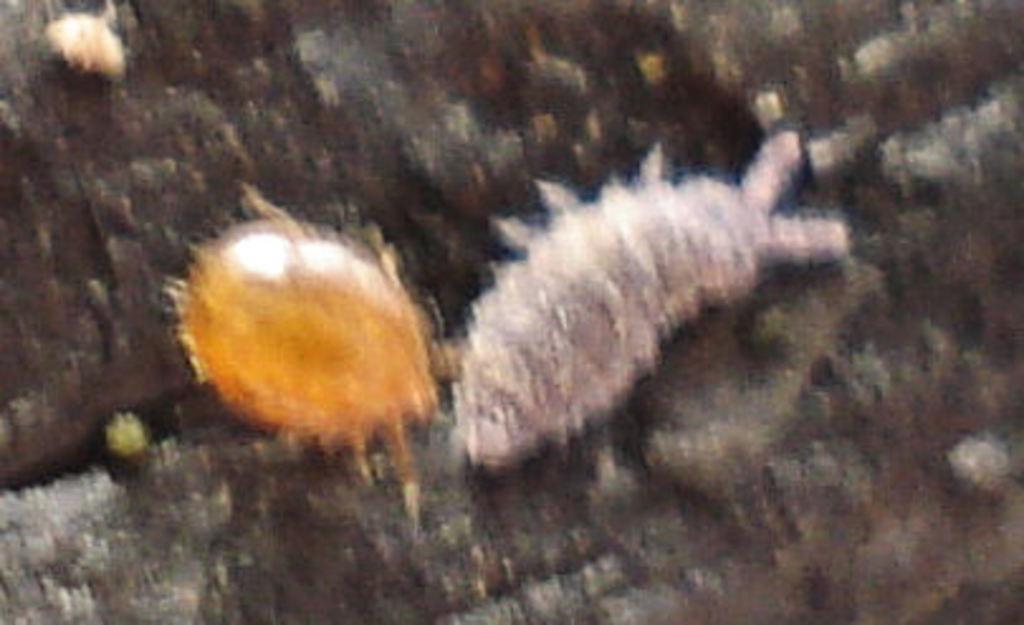Please provide a concise description of this image. In the given image i can see a insects with slightly blur. 